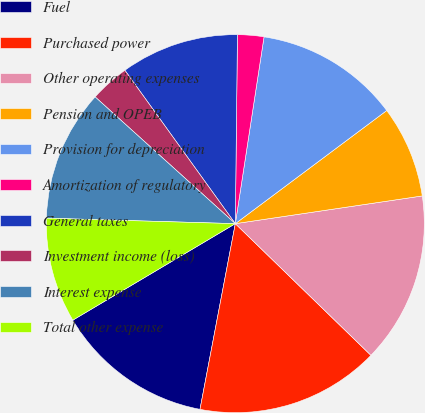Convert chart to OTSL. <chart><loc_0><loc_0><loc_500><loc_500><pie_chart><fcel>Fuel<fcel>Purchased power<fcel>Other operating expenses<fcel>Pension and OPEB<fcel>Provision for depreciation<fcel>Amortization of regulatory<fcel>General taxes<fcel>Investment income (loss)<fcel>Interest expense<fcel>Total other expense<nl><fcel>13.48%<fcel>15.73%<fcel>14.61%<fcel>7.87%<fcel>12.36%<fcel>2.25%<fcel>10.11%<fcel>3.37%<fcel>11.24%<fcel>8.99%<nl></chart> 